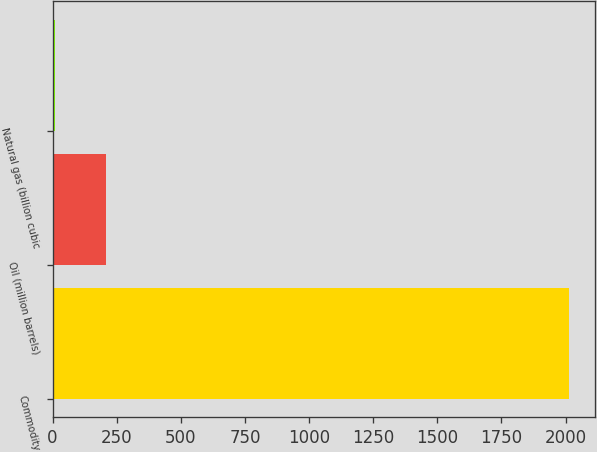Convert chart to OTSL. <chart><loc_0><loc_0><loc_500><loc_500><bar_chart><fcel>Commodity<fcel>Oil (million barrels)<fcel>Natural gas (billion cubic<nl><fcel>2013<fcel>210.3<fcel>10<nl></chart> 